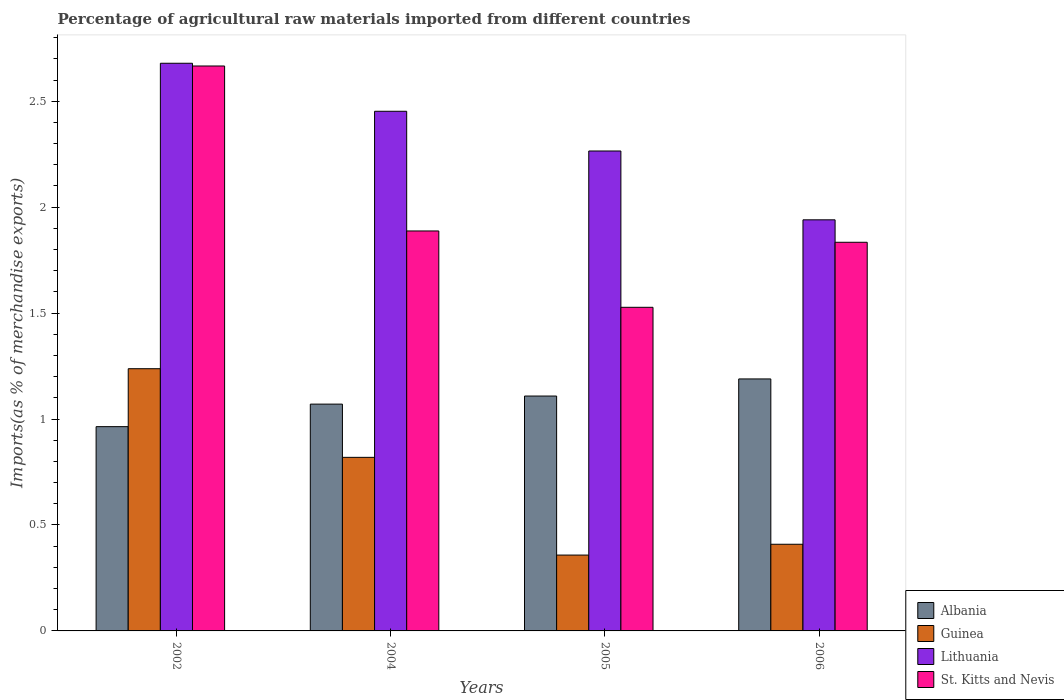Are the number of bars per tick equal to the number of legend labels?
Offer a terse response. Yes. In how many cases, is the number of bars for a given year not equal to the number of legend labels?
Keep it short and to the point. 0. What is the percentage of imports to different countries in Lithuania in 2004?
Your response must be concise. 2.45. Across all years, what is the maximum percentage of imports to different countries in St. Kitts and Nevis?
Ensure brevity in your answer.  2.67. Across all years, what is the minimum percentage of imports to different countries in Albania?
Offer a very short reply. 0.96. In which year was the percentage of imports to different countries in Lithuania minimum?
Give a very brief answer. 2006. What is the total percentage of imports to different countries in Guinea in the graph?
Your answer should be compact. 2.82. What is the difference between the percentage of imports to different countries in Guinea in 2002 and that in 2005?
Your answer should be very brief. 0.88. What is the difference between the percentage of imports to different countries in Lithuania in 2006 and the percentage of imports to different countries in St. Kitts and Nevis in 2004?
Your answer should be very brief. 0.05. What is the average percentage of imports to different countries in Guinea per year?
Ensure brevity in your answer.  0.71. In the year 2004, what is the difference between the percentage of imports to different countries in Albania and percentage of imports to different countries in Lithuania?
Offer a very short reply. -1.38. What is the ratio of the percentage of imports to different countries in Guinea in 2005 to that in 2006?
Offer a very short reply. 0.88. Is the difference between the percentage of imports to different countries in Albania in 2002 and 2004 greater than the difference between the percentage of imports to different countries in Lithuania in 2002 and 2004?
Your answer should be very brief. No. What is the difference between the highest and the second highest percentage of imports to different countries in Albania?
Offer a very short reply. 0.08. What is the difference between the highest and the lowest percentage of imports to different countries in Lithuania?
Give a very brief answer. 0.74. In how many years, is the percentage of imports to different countries in Lithuania greater than the average percentage of imports to different countries in Lithuania taken over all years?
Keep it short and to the point. 2. Is it the case that in every year, the sum of the percentage of imports to different countries in Lithuania and percentage of imports to different countries in St. Kitts and Nevis is greater than the sum of percentage of imports to different countries in Guinea and percentage of imports to different countries in Albania?
Offer a terse response. No. What does the 3rd bar from the left in 2006 represents?
Your answer should be compact. Lithuania. What does the 4th bar from the right in 2006 represents?
Provide a succinct answer. Albania. Is it the case that in every year, the sum of the percentage of imports to different countries in Albania and percentage of imports to different countries in Guinea is greater than the percentage of imports to different countries in St. Kitts and Nevis?
Make the answer very short. No. Are all the bars in the graph horizontal?
Ensure brevity in your answer.  No. Where does the legend appear in the graph?
Give a very brief answer. Bottom right. What is the title of the graph?
Ensure brevity in your answer.  Percentage of agricultural raw materials imported from different countries. What is the label or title of the X-axis?
Offer a very short reply. Years. What is the label or title of the Y-axis?
Keep it short and to the point. Imports(as % of merchandise exports). What is the Imports(as % of merchandise exports) of Albania in 2002?
Offer a very short reply. 0.96. What is the Imports(as % of merchandise exports) of Guinea in 2002?
Provide a short and direct response. 1.24. What is the Imports(as % of merchandise exports) of Lithuania in 2002?
Ensure brevity in your answer.  2.68. What is the Imports(as % of merchandise exports) of St. Kitts and Nevis in 2002?
Your response must be concise. 2.67. What is the Imports(as % of merchandise exports) in Albania in 2004?
Make the answer very short. 1.07. What is the Imports(as % of merchandise exports) in Guinea in 2004?
Keep it short and to the point. 0.82. What is the Imports(as % of merchandise exports) in Lithuania in 2004?
Provide a succinct answer. 2.45. What is the Imports(as % of merchandise exports) in St. Kitts and Nevis in 2004?
Keep it short and to the point. 1.89. What is the Imports(as % of merchandise exports) in Albania in 2005?
Provide a short and direct response. 1.11. What is the Imports(as % of merchandise exports) in Guinea in 2005?
Your answer should be compact. 0.36. What is the Imports(as % of merchandise exports) of Lithuania in 2005?
Provide a short and direct response. 2.27. What is the Imports(as % of merchandise exports) of St. Kitts and Nevis in 2005?
Provide a succinct answer. 1.53. What is the Imports(as % of merchandise exports) in Albania in 2006?
Your response must be concise. 1.19. What is the Imports(as % of merchandise exports) of Guinea in 2006?
Provide a short and direct response. 0.41. What is the Imports(as % of merchandise exports) of Lithuania in 2006?
Provide a succinct answer. 1.94. What is the Imports(as % of merchandise exports) of St. Kitts and Nevis in 2006?
Provide a succinct answer. 1.83. Across all years, what is the maximum Imports(as % of merchandise exports) of Albania?
Offer a very short reply. 1.19. Across all years, what is the maximum Imports(as % of merchandise exports) in Guinea?
Provide a succinct answer. 1.24. Across all years, what is the maximum Imports(as % of merchandise exports) in Lithuania?
Give a very brief answer. 2.68. Across all years, what is the maximum Imports(as % of merchandise exports) of St. Kitts and Nevis?
Give a very brief answer. 2.67. Across all years, what is the minimum Imports(as % of merchandise exports) in Albania?
Your answer should be compact. 0.96. Across all years, what is the minimum Imports(as % of merchandise exports) in Guinea?
Make the answer very short. 0.36. Across all years, what is the minimum Imports(as % of merchandise exports) of Lithuania?
Your answer should be very brief. 1.94. Across all years, what is the minimum Imports(as % of merchandise exports) in St. Kitts and Nevis?
Offer a very short reply. 1.53. What is the total Imports(as % of merchandise exports) of Albania in the graph?
Your answer should be compact. 4.33. What is the total Imports(as % of merchandise exports) in Guinea in the graph?
Provide a short and direct response. 2.82. What is the total Imports(as % of merchandise exports) of Lithuania in the graph?
Ensure brevity in your answer.  9.34. What is the total Imports(as % of merchandise exports) in St. Kitts and Nevis in the graph?
Your answer should be compact. 7.92. What is the difference between the Imports(as % of merchandise exports) in Albania in 2002 and that in 2004?
Your answer should be very brief. -0.11. What is the difference between the Imports(as % of merchandise exports) in Guinea in 2002 and that in 2004?
Make the answer very short. 0.42. What is the difference between the Imports(as % of merchandise exports) of Lithuania in 2002 and that in 2004?
Provide a short and direct response. 0.23. What is the difference between the Imports(as % of merchandise exports) of St. Kitts and Nevis in 2002 and that in 2004?
Your answer should be compact. 0.78. What is the difference between the Imports(as % of merchandise exports) of Albania in 2002 and that in 2005?
Your answer should be compact. -0.14. What is the difference between the Imports(as % of merchandise exports) of Guinea in 2002 and that in 2005?
Your answer should be compact. 0.88. What is the difference between the Imports(as % of merchandise exports) of Lithuania in 2002 and that in 2005?
Your answer should be compact. 0.41. What is the difference between the Imports(as % of merchandise exports) in St. Kitts and Nevis in 2002 and that in 2005?
Give a very brief answer. 1.14. What is the difference between the Imports(as % of merchandise exports) of Albania in 2002 and that in 2006?
Provide a succinct answer. -0.23. What is the difference between the Imports(as % of merchandise exports) in Guinea in 2002 and that in 2006?
Offer a very short reply. 0.83. What is the difference between the Imports(as % of merchandise exports) of Lithuania in 2002 and that in 2006?
Offer a very short reply. 0.74. What is the difference between the Imports(as % of merchandise exports) of St. Kitts and Nevis in 2002 and that in 2006?
Ensure brevity in your answer.  0.83. What is the difference between the Imports(as % of merchandise exports) in Albania in 2004 and that in 2005?
Your answer should be compact. -0.04. What is the difference between the Imports(as % of merchandise exports) in Guinea in 2004 and that in 2005?
Ensure brevity in your answer.  0.46. What is the difference between the Imports(as % of merchandise exports) of Lithuania in 2004 and that in 2005?
Provide a succinct answer. 0.19. What is the difference between the Imports(as % of merchandise exports) in St. Kitts and Nevis in 2004 and that in 2005?
Your answer should be very brief. 0.36. What is the difference between the Imports(as % of merchandise exports) in Albania in 2004 and that in 2006?
Keep it short and to the point. -0.12. What is the difference between the Imports(as % of merchandise exports) in Guinea in 2004 and that in 2006?
Offer a very short reply. 0.41. What is the difference between the Imports(as % of merchandise exports) in Lithuania in 2004 and that in 2006?
Ensure brevity in your answer.  0.51. What is the difference between the Imports(as % of merchandise exports) of St. Kitts and Nevis in 2004 and that in 2006?
Give a very brief answer. 0.05. What is the difference between the Imports(as % of merchandise exports) of Albania in 2005 and that in 2006?
Your response must be concise. -0.08. What is the difference between the Imports(as % of merchandise exports) of Guinea in 2005 and that in 2006?
Offer a terse response. -0.05. What is the difference between the Imports(as % of merchandise exports) of Lithuania in 2005 and that in 2006?
Provide a short and direct response. 0.32. What is the difference between the Imports(as % of merchandise exports) of St. Kitts and Nevis in 2005 and that in 2006?
Offer a very short reply. -0.31. What is the difference between the Imports(as % of merchandise exports) in Albania in 2002 and the Imports(as % of merchandise exports) in Guinea in 2004?
Keep it short and to the point. 0.14. What is the difference between the Imports(as % of merchandise exports) of Albania in 2002 and the Imports(as % of merchandise exports) of Lithuania in 2004?
Your answer should be very brief. -1.49. What is the difference between the Imports(as % of merchandise exports) in Albania in 2002 and the Imports(as % of merchandise exports) in St. Kitts and Nevis in 2004?
Offer a very short reply. -0.92. What is the difference between the Imports(as % of merchandise exports) of Guinea in 2002 and the Imports(as % of merchandise exports) of Lithuania in 2004?
Make the answer very short. -1.22. What is the difference between the Imports(as % of merchandise exports) of Guinea in 2002 and the Imports(as % of merchandise exports) of St. Kitts and Nevis in 2004?
Provide a short and direct response. -0.65. What is the difference between the Imports(as % of merchandise exports) of Lithuania in 2002 and the Imports(as % of merchandise exports) of St. Kitts and Nevis in 2004?
Your answer should be compact. 0.79. What is the difference between the Imports(as % of merchandise exports) in Albania in 2002 and the Imports(as % of merchandise exports) in Guinea in 2005?
Ensure brevity in your answer.  0.61. What is the difference between the Imports(as % of merchandise exports) in Albania in 2002 and the Imports(as % of merchandise exports) in Lithuania in 2005?
Keep it short and to the point. -1.3. What is the difference between the Imports(as % of merchandise exports) in Albania in 2002 and the Imports(as % of merchandise exports) in St. Kitts and Nevis in 2005?
Offer a terse response. -0.56. What is the difference between the Imports(as % of merchandise exports) in Guinea in 2002 and the Imports(as % of merchandise exports) in Lithuania in 2005?
Make the answer very short. -1.03. What is the difference between the Imports(as % of merchandise exports) of Guinea in 2002 and the Imports(as % of merchandise exports) of St. Kitts and Nevis in 2005?
Provide a short and direct response. -0.29. What is the difference between the Imports(as % of merchandise exports) in Lithuania in 2002 and the Imports(as % of merchandise exports) in St. Kitts and Nevis in 2005?
Offer a terse response. 1.15. What is the difference between the Imports(as % of merchandise exports) of Albania in 2002 and the Imports(as % of merchandise exports) of Guinea in 2006?
Provide a short and direct response. 0.56. What is the difference between the Imports(as % of merchandise exports) in Albania in 2002 and the Imports(as % of merchandise exports) in Lithuania in 2006?
Your response must be concise. -0.98. What is the difference between the Imports(as % of merchandise exports) of Albania in 2002 and the Imports(as % of merchandise exports) of St. Kitts and Nevis in 2006?
Offer a terse response. -0.87. What is the difference between the Imports(as % of merchandise exports) in Guinea in 2002 and the Imports(as % of merchandise exports) in Lithuania in 2006?
Keep it short and to the point. -0.7. What is the difference between the Imports(as % of merchandise exports) of Guinea in 2002 and the Imports(as % of merchandise exports) of St. Kitts and Nevis in 2006?
Your response must be concise. -0.6. What is the difference between the Imports(as % of merchandise exports) in Lithuania in 2002 and the Imports(as % of merchandise exports) in St. Kitts and Nevis in 2006?
Your answer should be compact. 0.84. What is the difference between the Imports(as % of merchandise exports) of Albania in 2004 and the Imports(as % of merchandise exports) of Guinea in 2005?
Offer a terse response. 0.71. What is the difference between the Imports(as % of merchandise exports) in Albania in 2004 and the Imports(as % of merchandise exports) in Lithuania in 2005?
Offer a very short reply. -1.19. What is the difference between the Imports(as % of merchandise exports) of Albania in 2004 and the Imports(as % of merchandise exports) of St. Kitts and Nevis in 2005?
Make the answer very short. -0.46. What is the difference between the Imports(as % of merchandise exports) in Guinea in 2004 and the Imports(as % of merchandise exports) in Lithuania in 2005?
Give a very brief answer. -1.45. What is the difference between the Imports(as % of merchandise exports) of Guinea in 2004 and the Imports(as % of merchandise exports) of St. Kitts and Nevis in 2005?
Provide a succinct answer. -0.71. What is the difference between the Imports(as % of merchandise exports) of Lithuania in 2004 and the Imports(as % of merchandise exports) of St. Kitts and Nevis in 2005?
Make the answer very short. 0.93. What is the difference between the Imports(as % of merchandise exports) of Albania in 2004 and the Imports(as % of merchandise exports) of Guinea in 2006?
Provide a short and direct response. 0.66. What is the difference between the Imports(as % of merchandise exports) of Albania in 2004 and the Imports(as % of merchandise exports) of Lithuania in 2006?
Ensure brevity in your answer.  -0.87. What is the difference between the Imports(as % of merchandise exports) in Albania in 2004 and the Imports(as % of merchandise exports) in St. Kitts and Nevis in 2006?
Your answer should be compact. -0.76. What is the difference between the Imports(as % of merchandise exports) in Guinea in 2004 and the Imports(as % of merchandise exports) in Lithuania in 2006?
Your answer should be very brief. -1.12. What is the difference between the Imports(as % of merchandise exports) in Guinea in 2004 and the Imports(as % of merchandise exports) in St. Kitts and Nevis in 2006?
Your response must be concise. -1.02. What is the difference between the Imports(as % of merchandise exports) in Lithuania in 2004 and the Imports(as % of merchandise exports) in St. Kitts and Nevis in 2006?
Offer a very short reply. 0.62. What is the difference between the Imports(as % of merchandise exports) of Albania in 2005 and the Imports(as % of merchandise exports) of Guinea in 2006?
Provide a short and direct response. 0.7. What is the difference between the Imports(as % of merchandise exports) in Albania in 2005 and the Imports(as % of merchandise exports) in Lithuania in 2006?
Offer a very short reply. -0.83. What is the difference between the Imports(as % of merchandise exports) in Albania in 2005 and the Imports(as % of merchandise exports) in St. Kitts and Nevis in 2006?
Your answer should be very brief. -0.73. What is the difference between the Imports(as % of merchandise exports) in Guinea in 2005 and the Imports(as % of merchandise exports) in Lithuania in 2006?
Provide a short and direct response. -1.58. What is the difference between the Imports(as % of merchandise exports) of Guinea in 2005 and the Imports(as % of merchandise exports) of St. Kitts and Nevis in 2006?
Offer a terse response. -1.48. What is the difference between the Imports(as % of merchandise exports) in Lithuania in 2005 and the Imports(as % of merchandise exports) in St. Kitts and Nevis in 2006?
Your response must be concise. 0.43. What is the average Imports(as % of merchandise exports) in Albania per year?
Offer a very short reply. 1.08. What is the average Imports(as % of merchandise exports) in Guinea per year?
Give a very brief answer. 0.71. What is the average Imports(as % of merchandise exports) in Lithuania per year?
Your answer should be very brief. 2.33. What is the average Imports(as % of merchandise exports) in St. Kitts and Nevis per year?
Provide a short and direct response. 1.98. In the year 2002, what is the difference between the Imports(as % of merchandise exports) in Albania and Imports(as % of merchandise exports) in Guinea?
Your answer should be compact. -0.27. In the year 2002, what is the difference between the Imports(as % of merchandise exports) in Albania and Imports(as % of merchandise exports) in Lithuania?
Your answer should be very brief. -1.72. In the year 2002, what is the difference between the Imports(as % of merchandise exports) in Albania and Imports(as % of merchandise exports) in St. Kitts and Nevis?
Ensure brevity in your answer.  -1.7. In the year 2002, what is the difference between the Imports(as % of merchandise exports) of Guinea and Imports(as % of merchandise exports) of Lithuania?
Make the answer very short. -1.44. In the year 2002, what is the difference between the Imports(as % of merchandise exports) of Guinea and Imports(as % of merchandise exports) of St. Kitts and Nevis?
Your answer should be very brief. -1.43. In the year 2002, what is the difference between the Imports(as % of merchandise exports) in Lithuania and Imports(as % of merchandise exports) in St. Kitts and Nevis?
Provide a short and direct response. 0.01. In the year 2004, what is the difference between the Imports(as % of merchandise exports) of Albania and Imports(as % of merchandise exports) of Guinea?
Ensure brevity in your answer.  0.25. In the year 2004, what is the difference between the Imports(as % of merchandise exports) in Albania and Imports(as % of merchandise exports) in Lithuania?
Keep it short and to the point. -1.38. In the year 2004, what is the difference between the Imports(as % of merchandise exports) of Albania and Imports(as % of merchandise exports) of St. Kitts and Nevis?
Your response must be concise. -0.82. In the year 2004, what is the difference between the Imports(as % of merchandise exports) of Guinea and Imports(as % of merchandise exports) of Lithuania?
Keep it short and to the point. -1.63. In the year 2004, what is the difference between the Imports(as % of merchandise exports) of Guinea and Imports(as % of merchandise exports) of St. Kitts and Nevis?
Give a very brief answer. -1.07. In the year 2004, what is the difference between the Imports(as % of merchandise exports) in Lithuania and Imports(as % of merchandise exports) in St. Kitts and Nevis?
Your response must be concise. 0.56. In the year 2005, what is the difference between the Imports(as % of merchandise exports) in Albania and Imports(as % of merchandise exports) in Guinea?
Ensure brevity in your answer.  0.75. In the year 2005, what is the difference between the Imports(as % of merchandise exports) in Albania and Imports(as % of merchandise exports) in Lithuania?
Make the answer very short. -1.16. In the year 2005, what is the difference between the Imports(as % of merchandise exports) in Albania and Imports(as % of merchandise exports) in St. Kitts and Nevis?
Keep it short and to the point. -0.42. In the year 2005, what is the difference between the Imports(as % of merchandise exports) of Guinea and Imports(as % of merchandise exports) of Lithuania?
Provide a succinct answer. -1.91. In the year 2005, what is the difference between the Imports(as % of merchandise exports) in Guinea and Imports(as % of merchandise exports) in St. Kitts and Nevis?
Your answer should be compact. -1.17. In the year 2005, what is the difference between the Imports(as % of merchandise exports) of Lithuania and Imports(as % of merchandise exports) of St. Kitts and Nevis?
Ensure brevity in your answer.  0.74. In the year 2006, what is the difference between the Imports(as % of merchandise exports) of Albania and Imports(as % of merchandise exports) of Guinea?
Offer a terse response. 0.78. In the year 2006, what is the difference between the Imports(as % of merchandise exports) of Albania and Imports(as % of merchandise exports) of Lithuania?
Your answer should be very brief. -0.75. In the year 2006, what is the difference between the Imports(as % of merchandise exports) in Albania and Imports(as % of merchandise exports) in St. Kitts and Nevis?
Keep it short and to the point. -0.65. In the year 2006, what is the difference between the Imports(as % of merchandise exports) of Guinea and Imports(as % of merchandise exports) of Lithuania?
Ensure brevity in your answer.  -1.53. In the year 2006, what is the difference between the Imports(as % of merchandise exports) in Guinea and Imports(as % of merchandise exports) in St. Kitts and Nevis?
Ensure brevity in your answer.  -1.43. In the year 2006, what is the difference between the Imports(as % of merchandise exports) of Lithuania and Imports(as % of merchandise exports) of St. Kitts and Nevis?
Your response must be concise. 0.11. What is the ratio of the Imports(as % of merchandise exports) of Albania in 2002 to that in 2004?
Ensure brevity in your answer.  0.9. What is the ratio of the Imports(as % of merchandise exports) of Guinea in 2002 to that in 2004?
Offer a very short reply. 1.51. What is the ratio of the Imports(as % of merchandise exports) of Lithuania in 2002 to that in 2004?
Your answer should be very brief. 1.09. What is the ratio of the Imports(as % of merchandise exports) in St. Kitts and Nevis in 2002 to that in 2004?
Your answer should be very brief. 1.41. What is the ratio of the Imports(as % of merchandise exports) of Albania in 2002 to that in 2005?
Your answer should be very brief. 0.87. What is the ratio of the Imports(as % of merchandise exports) of Guinea in 2002 to that in 2005?
Your response must be concise. 3.46. What is the ratio of the Imports(as % of merchandise exports) of Lithuania in 2002 to that in 2005?
Ensure brevity in your answer.  1.18. What is the ratio of the Imports(as % of merchandise exports) in St. Kitts and Nevis in 2002 to that in 2005?
Your response must be concise. 1.75. What is the ratio of the Imports(as % of merchandise exports) in Albania in 2002 to that in 2006?
Give a very brief answer. 0.81. What is the ratio of the Imports(as % of merchandise exports) in Guinea in 2002 to that in 2006?
Offer a terse response. 3.03. What is the ratio of the Imports(as % of merchandise exports) of Lithuania in 2002 to that in 2006?
Offer a terse response. 1.38. What is the ratio of the Imports(as % of merchandise exports) of St. Kitts and Nevis in 2002 to that in 2006?
Provide a short and direct response. 1.45. What is the ratio of the Imports(as % of merchandise exports) in Albania in 2004 to that in 2005?
Provide a short and direct response. 0.97. What is the ratio of the Imports(as % of merchandise exports) in Guinea in 2004 to that in 2005?
Offer a very short reply. 2.29. What is the ratio of the Imports(as % of merchandise exports) in Lithuania in 2004 to that in 2005?
Provide a succinct answer. 1.08. What is the ratio of the Imports(as % of merchandise exports) of St. Kitts and Nevis in 2004 to that in 2005?
Keep it short and to the point. 1.24. What is the ratio of the Imports(as % of merchandise exports) of Albania in 2004 to that in 2006?
Ensure brevity in your answer.  0.9. What is the ratio of the Imports(as % of merchandise exports) of Guinea in 2004 to that in 2006?
Your answer should be compact. 2. What is the ratio of the Imports(as % of merchandise exports) of Lithuania in 2004 to that in 2006?
Your answer should be compact. 1.26. What is the ratio of the Imports(as % of merchandise exports) in St. Kitts and Nevis in 2004 to that in 2006?
Give a very brief answer. 1.03. What is the ratio of the Imports(as % of merchandise exports) of Albania in 2005 to that in 2006?
Your answer should be very brief. 0.93. What is the ratio of the Imports(as % of merchandise exports) of Guinea in 2005 to that in 2006?
Keep it short and to the point. 0.88. What is the ratio of the Imports(as % of merchandise exports) in Lithuania in 2005 to that in 2006?
Give a very brief answer. 1.17. What is the ratio of the Imports(as % of merchandise exports) of St. Kitts and Nevis in 2005 to that in 2006?
Your response must be concise. 0.83. What is the difference between the highest and the second highest Imports(as % of merchandise exports) in Albania?
Your answer should be compact. 0.08. What is the difference between the highest and the second highest Imports(as % of merchandise exports) of Guinea?
Make the answer very short. 0.42. What is the difference between the highest and the second highest Imports(as % of merchandise exports) of Lithuania?
Offer a very short reply. 0.23. What is the difference between the highest and the second highest Imports(as % of merchandise exports) of St. Kitts and Nevis?
Offer a terse response. 0.78. What is the difference between the highest and the lowest Imports(as % of merchandise exports) of Albania?
Your response must be concise. 0.23. What is the difference between the highest and the lowest Imports(as % of merchandise exports) in Guinea?
Ensure brevity in your answer.  0.88. What is the difference between the highest and the lowest Imports(as % of merchandise exports) in Lithuania?
Ensure brevity in your answer.  0.74. What is the difference between the highest and the lowest Imports(as % of merchandise exports) of St. Kitts and Nevis?
Keep it short and to the point. 1.14. 